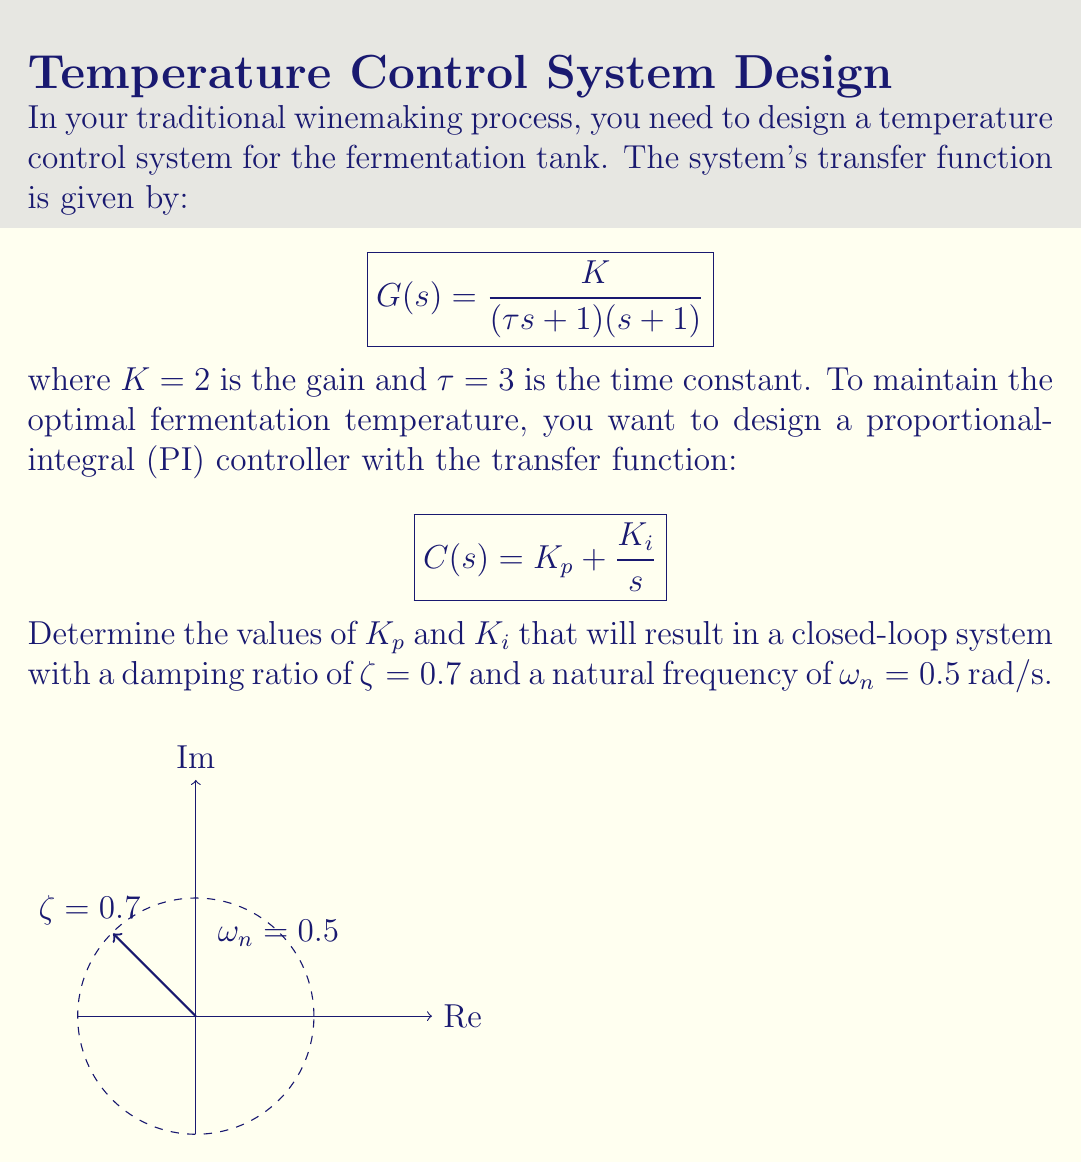Teach me how to tackle this problem. To solve this problem, we'll follow these steps:

1) The characteristic equation of the closed-loop system is:
   $$1 + G(s)C(s) = 0$$

2) Substituting the given transfer functions:
   $$1 + \frac{2}{(3s + 1)(s + 1)}(K_p + \frac{K_i}{s}) = 0$$

3) Expanding this equation:
   $$3s^2 + s + 2K_p + \frac{2K_i}{s} = 0$$

4) Multiplying both sides by $s$:
   $$3s^3 + s^2 + 2K_ps + 2K_i = 0$$

5) For a second-order system with damping ratio $ζ$ and natural frequency $ω_n$, the characteristic equation is:
   $$s^2 + 2ζω_ns + ω_n^2 = 0$$

6) Comparing our equation with the standard form:
   $$3s^3 + s^2 + 2K_ps + 2K_i = 0$$
   $$s^2 + \frac{2K_p}{3}s + \frac{2K_i}{3} = 0$$

7) Equating coefficients:
   $$\frac{2K_p}{3} = 2ζω_n = 2(0.7)(0.5) = 0.7$$
   $$\frac{2K_i}{3} = ω_n^2 = 0.5^2 = 0.25$$

8) Solving for $K_p$ and $K_i$:
   $$K_p = \frac{3 * 0.7}{2} = 1.05$$
   $$K_i = \frac{3 * 0.25}{2} = 0.375$$

Therefore, the PI controller parameters should be $K_p = 1.05$ and $K_i = 0.375$.
Answer: $K_p = 1.05$, $K_i = 0.375$ 